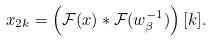<formula> <loc_0><loc_0><loc_500><loc_500>x _ { 2 k } = \left ( \mathcal { F } ( x ) \ast \mathcal { F } ( w _ { \beta } ^ { - 1 } ) \right ) [ k ] .</formula> 